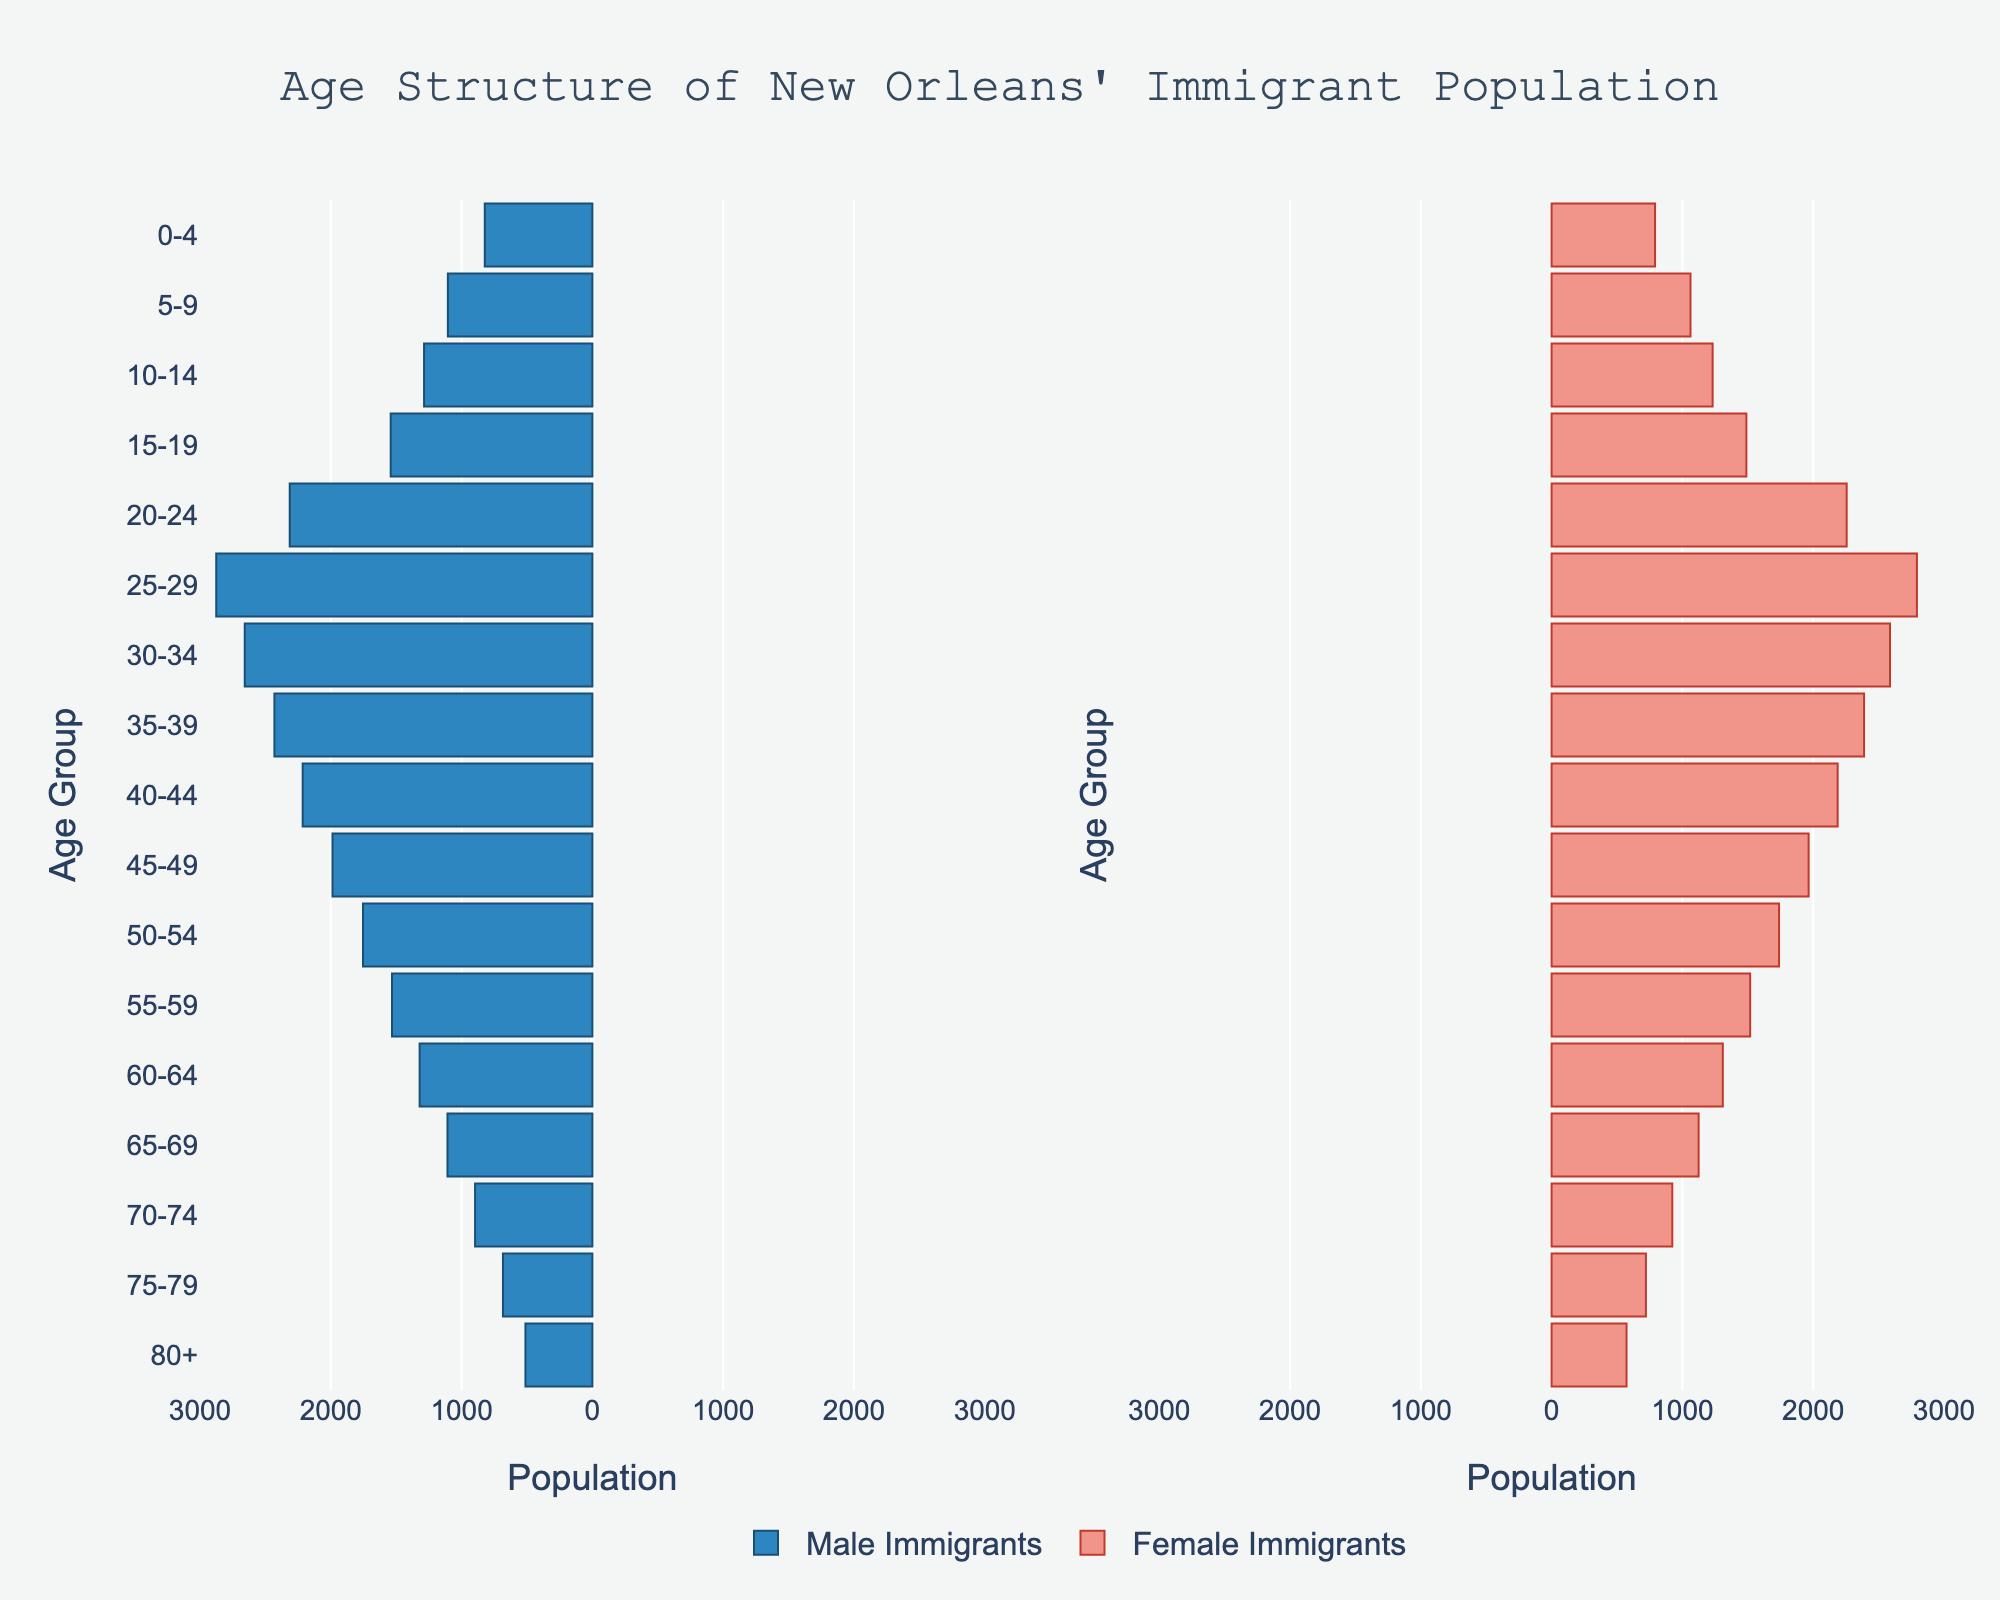What's the title of the figure? The title is usually found at the top of the figure. It summarizes what the entire chart is about and provides context.
Answer: Age Structure of New Orleans' Immigrant Population What do the two different colors in the bars represent? By looking at the legend, we can see that the blue bars represent male immigrants, and the pink bars represent female immigrants.
Answer: Male immigrants and Female immigrants Which age group has the highest number of male immigrants? By examining the length of the blue bars, the age group 25-29 has the longest bar, indicating the highest number of male immigrants.
Answer: 25-29 How many female immigrants are there in the 20-24 age group? Find the corresponding pink bar for the 20-24 age group and read the value. The length of the bar represents 2256 female immigrants.
Answer: 2256 Which age group has more female immigrants than male immigrants? Compare the pink and blue bars for each age group, and find that in the 80+ group, the pink bar is longer than the blue bar, indicating more female immigrants.
Answer: 80+ What's the total number of immigrants (both male and female) in the age group 0-4? Sum up the male and female counts for the 0-4 age group: 823 (male) + 791 (female) = 1614.
Answer: 1614 Which age group shows the most significant difference between male and female immigrants? Calculate the difference between male and female counts for each age group: (2876 - 2793 = 83), which is the largest difference for the 25-29 age group.
Answer: 25-29 What's the average number of immigrants for males aged 40-49? Sum the male immigrants in the 40-44 and 45-49 age groups: 2215 + 1987, then divide by 2.
Answer: 2101 Is the population of female immigrants aged 50-54 higher than that of male immigrants aged 55-59? Compare the values: 1739 (female, 50-54) vs. 1532 (male, 55-59). 1739 is greater than 1532.
Answer: Yes What is the approximate range of the population for each gender in the pyramid? By looking at the ticks on the x-axis, the population range is from 0 to approximately 3000 for both genders.
Answer: 0 to 3000 